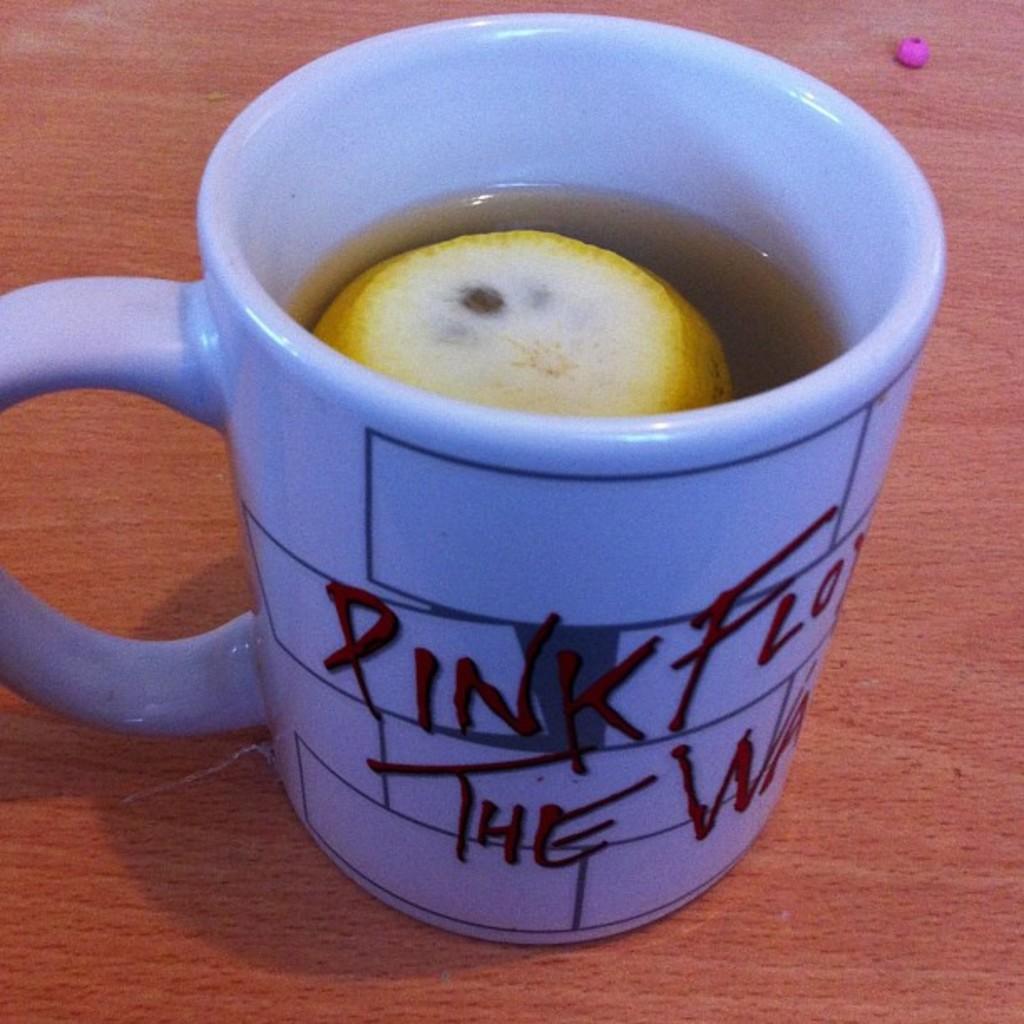What color is cited on the mug?
Ensure brevity in your answer.  Pink. 